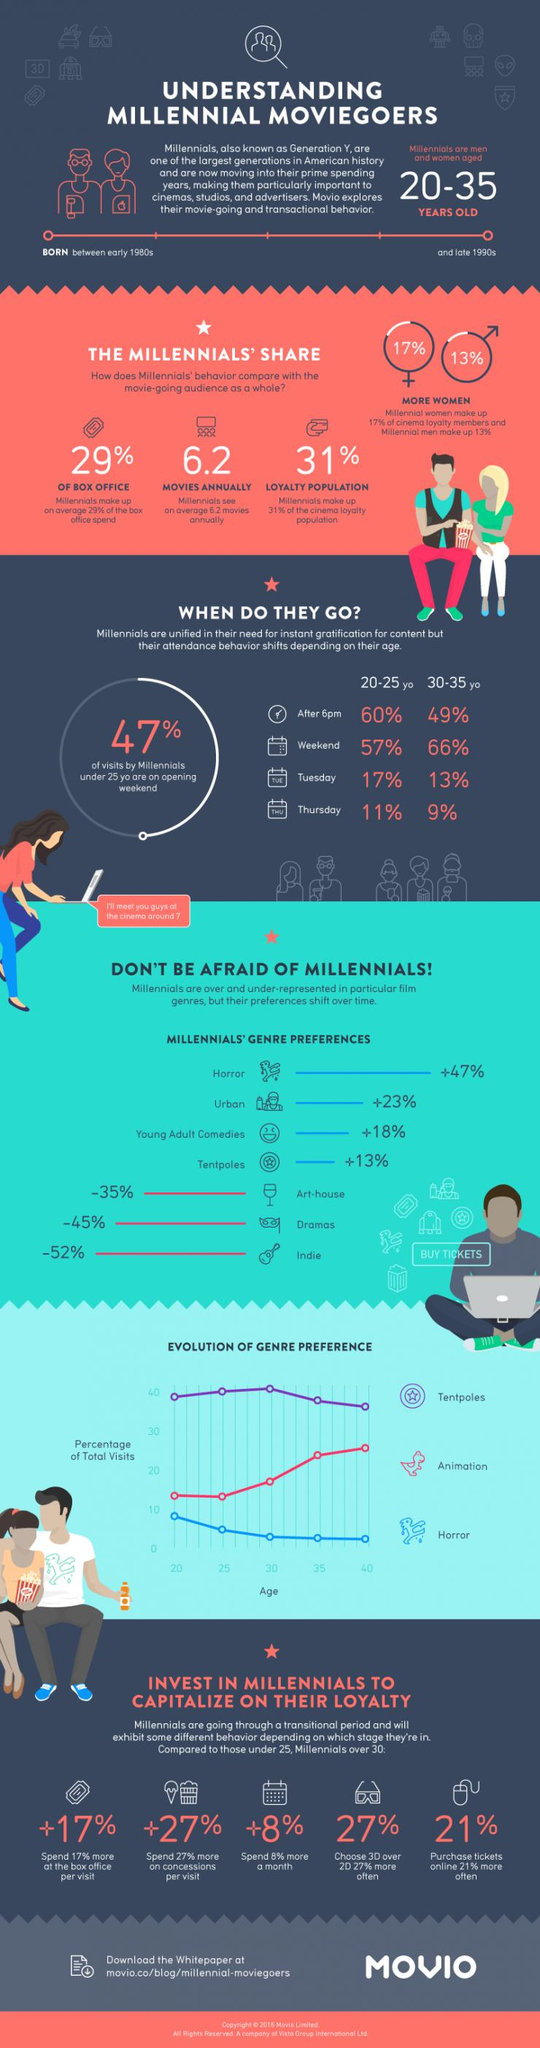Outline some significant characteristics in this image. A recent study has revealed that 41% of millennials prefer urban and young adult comedies. Millennial women dominate the cinema loyalty members in terms of gender. It is evident that 30-35 year old individuals prefer the weekend days. Seventy-one percent of box office revenue is generated by individuals who are not millennials. Si se sabe que el 69% de la población leal no son millennials 